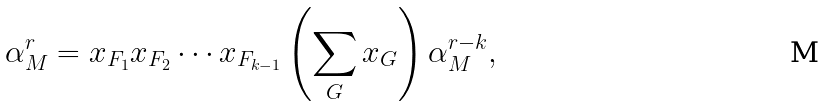<formula> <loc_0><loc_0><loc_500><loc_500>\alpha _ { M } ^ { r } = x _ { F _ { 1 } } x _ { F _ { 2 } } \cdots x _ { F _ { k - 1 } } \left ( \sum _ { G } x _ { G } \right ) \alpha _ { M } ^ { r - k } ,</formula> 